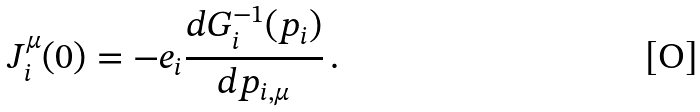Convert formula to latex. <formula><loc_0><loc_0><loc_500><loc_500>J ^ { \mu } _ { i } ( 0 ) = - e _ { i } \frac { d G _ { i } ^ { - 1 } ( p _ { i } ) } { d p _ { i , \mu } } \, .</formula> 